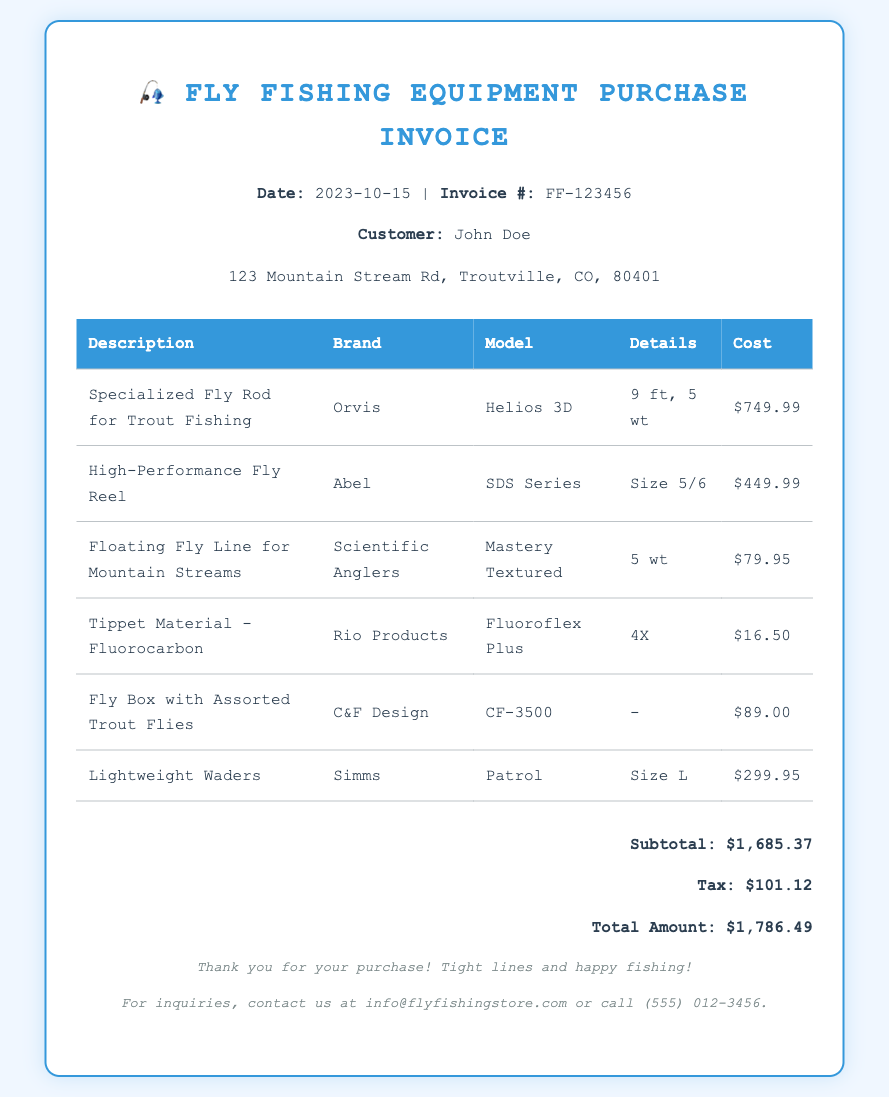What is the date of the invoice? The date of the invoice can be found in the header section of the document.
Answer: 2023-10-15 What is the total amount due? The total amount is located in the summary section of the invoice.
Answer: $1,786.49 What is the brand of the specialized fly rod? The brand of the specialized fly rod is mentioned next to its description.
Answer: Orvis How much does the fly box with assorted trout flies cost? The cost of the fly box is provided in the table under the cost column.
Answer: $89.00 What model is the high-performance fly reel? The model is specified in the table next to the description of the high-performance fly reel.
Answer: SDS Series What was the tax amount applied? The tax amount is listed in the summary section of the invoice.
Answer: $101.12 How many items are listed in the invoice? The number of items can be counted from the rows in the table of the invoice.
Answer: 6 Which company's product is the lightweight waders? The manufacturer of the lightweight waders is indicated in the product listing.
Answer: Simms What is the weight specification of the floating fly line? The weight specification is detailed in the description column of the relevant product.
Answer: 5 wt 